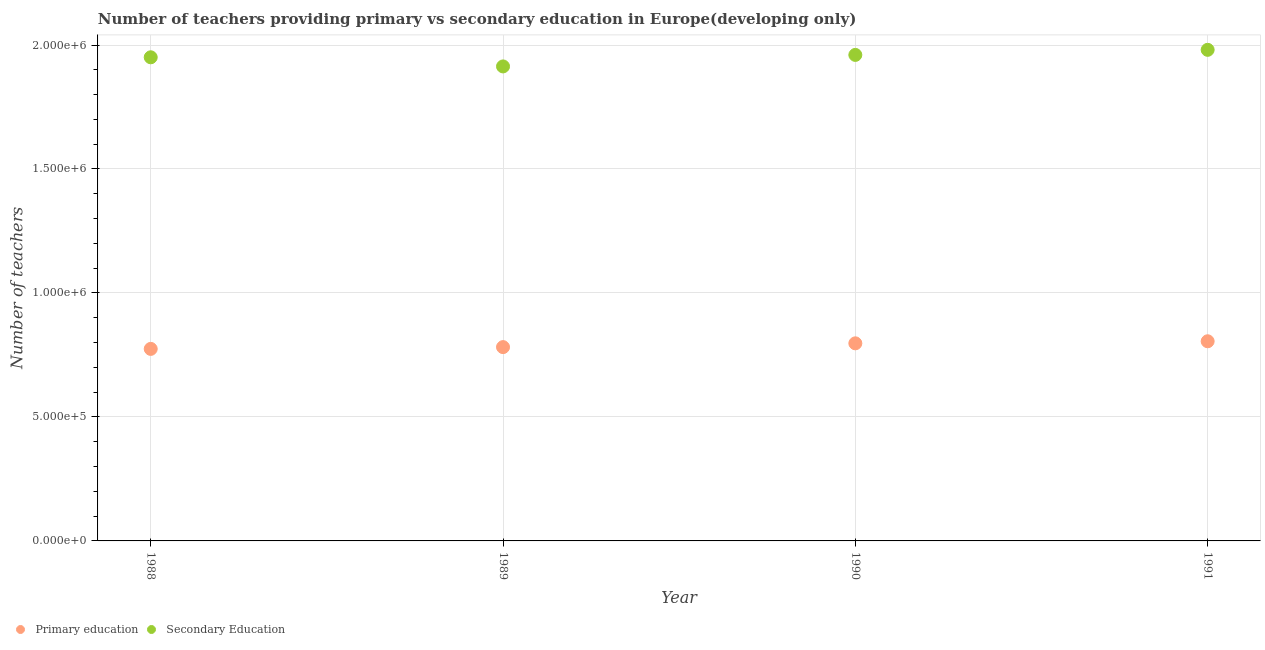What is the number of primary teachers in 1991?
Your answer should be compact. 8.05e+05. Across all years, what is the maximum number of primary teachers?
Make the answer very short. 8.05e+05. Across all years, what is the minimum number of secondary teachers?
Your response must be concise. 1.91e+06. In which year was the number of secondary teachers maximum?
Your answer should be very brief. 1991. What is the total number of primary teachers in the graph?
Give a very brief answer. 3.16e+06. What is the difference between the number of secondary teachers in 1989 and that in 1991?
Provide a succinct answer. -6.69e+04. What is the difference between the number of primary teachers in 1990 and the number of secondary teachers in 1991?
Your answer should be very brief. -1.18e+06. What is the average number of secondary teachers per year?
Give a very brief answer. 1.95e+06. In the year 1988, what is the difference between the number of primary teachers and number of secondary teachers?
Provide a succinct answer. -1.18e+06. What is the ratio of the number of primary teachers in 1988 to that in 1989?
Make the answer very short. 0.99. Is the difference between the number of primary teachers in 1989 and 1991 greater than the difference between the number of secondary teachers in 1989 and 1991?
Offer a very short reply. Yes. What is the difference between the highest and the second highest number of primary teachers?
Make the answer very short. 8311.06. What is the difference between the highest and the lowest number of primary teachers?
Make the answer very short. 3.07e+04. Is the sum of the number of secondary teachers in 1990 and 1991 greater than the maximum number of primary teachers across all years?
Offer a terse response. Yes. Is the number of secondary teachers strictly greater than the number of primary teachers over the years?
Your response must be concise. Yes. How many years are there in the graph?
Offer a terse response. 4. What is the difference between two consecutive major ticks on the Y-axis?
Provide a succinct answer. 5.00e+05. Does the graph contain any zero values?
Give a very brief answer. No. Does the graph contain grids?
Ensure brevity in your answer.  Yes. Where does the legend appear in the graph?
Offer a very short reply. Bottom left. How many legend labels are there?
Your answer should be compact. 2. How are the legend labels stacked?
Make the answer very short. Horizontal. What is the title of the graph?
Offer a terse response. Number of teachers providing primary vs secondary education in Europe(developing only). Does "Gasoline" appear as one of the legend labels in the graph?
Give a very brief answer. No. What is the label or title of the Y-axis?
Offer a very short reply. Number of teachers. What is the Number of teachers in Primary education in 1988?
Your response must be concise. 7.74e+05. What is the Number of teachers of Secondary Education in 1988?
Give a very brief answer. 1.95e+06. What is the Number of teachers in Primary education in 1989?
Keep it short and to the point. 7.82e+05. What is the Number of teachers of Secondary Education in 1989?
Give a very brief answer. 1.91e+06. What is the Number of teachers in Primary education in 1990?
Your answer should be compact. 7.97e+05. What is the Number of teachers in Secondary Education in 1990?
Your answer should be very brief. 1.96e+06. What is the Number of teachers in Primary education in 1991?
Your response must be concise. 8.05e+05. What is the Number of teachers in Secondary Education in 1991?
Ensure brevity in your answer.  1.98e+06. Across all years, what is the maximum Number of teachers in Primary education?
Keep it short and to the point. 8.05e+05. Across all years, what is the maximum Number of teachers in Secondary Education?
Make the answer very short. 1.98e+06. Across all years, what is the minimum Number of teachers in Primary education?
Provide a short and direct response. 7.74e+05. Across all years, what is the minimum Number of teachers in Secondary Education?
Give a very brief answer. 1.91e+06. What is the total Number of teachers of Primary education in the graph?
Ensure brevity in your answer.  3.16e+06. What is the total Number of teachers in Secondary Education in the graph?
Offer a terse response. 7.80e+06. What is the difference between the Number of teachers in Primary education in 1988 and that in 1989?
Your answer should be compact. -7168.81. What is the difference between the Number of teachers of Secondary Education in 1988 and that in 1989?
Your response must be concise. 3.68e+04. What is the difference between the Number of teachers in Primary education in 1988 and that in 1990?
Your answer should be very brief. -2.24e+04. What is the difference between the Number of teachers in Secondary Education in 1988 and that in 1990?
Offer a very short reply. -9607.5. What is the difference between the Number of teachers in Primary education in 1988 and that in 1991?
Keep it short and to the point. -3.07e+04. What is the difference between the Number of teachers in Secondary Education in 1988 and that in 1991?
Offer a very short reply. -3.01e+04. What is the difference between the Number of teachers of Primary education in 1989 and that in 1990?
Your answer should be very brief. -1.53e+04. What is the difference between the Number of teachers in Secondary Education in 1989 and that in 1990?
Offer a very short reply. -4.64e+04. What is the difference between the Number of teachers in Primary education in 1989 and that in 1991?
Offer a very short reply. -2.36e+04. What is the difference between the Number of teachers in Secondary Education in 1989 and that in 1991?
Provide a succinct answer. -6.69e+04. What is the difference between the Number of teachers in Primary education in 1990 and that in 1991?
Your answer should be compact. -8311.06. What is the difference between the Number of teachers in Secondary Education in 1990 and that in 1991?
Give a very brief answer. -2.05e+04. What is the difference between the Number of teachers in Primary education in 1988 and the Number of teachers in Secondary Education in 1989?
Offer a terse response. -1.14e+06. What is the difference between the Number of teachers of Primary education in 1988 and the Number of teachers of Secondary Education in 1990?
Provide a short and direct response. -1.19e+06. What is the difference between the Number of teachers in Primary education in 1988 and the Number of teachers in Secondary Education in 1991?
Provide a succinct answer. -1.21e+06. What is the difference between the Number of teachers in Primary education in 1989 and the Number of teachers in Secondary Education in 1990?
Offer a very short reply. -1.18e+06. What is the difference between the Number of teachers in Primary education in 1989 and the Number of teachers in Secondary Education in 1991?
Your answer should be compact. -1.20e+06. What is the difference between the Number of teachers of Primary education in 1990 and the Number of teachers of Secondary Education in 1991?
Provide a short and direct response. -1.18e+06. What is the average Number of teachers of Primary education per year?
Ensure brevity in your answer.  7.90e+05. What is the average Number of teachers in Secondary Education per year?
Your answer should be compact. 1.95e+06. In the year 1988, what is the difference between the Number of teachers of Primary education and Number of teachers of Secondary Education?
Your response must be concise. -1.18e+06. In the year 1989, what is the difference between the Number of teachers in Primary education and Number of teachers in Secondary Education?
Your answer should be very brief. -1.13e+06. In the year 1990, what is the difference between the Number of teachers in Primary education and Number of teachers in Secondary Education?
Provide a succinct answer. -1.16e+06. In the year 1991, what is the difference between the Number of teachers in Primary education and Number of teachers in Secondary Education?
Offer a very short reply. -1.18e+06. What is the ratio of the Number of teachers in Primary education in 1988 to that in 1989?
Offer a terse response. 0.99. What is the ratio of the Number of teachers in Secondary Education in 1988 to that in 1989?
Your answer should be very brief. 1.02. What is the ratio of the Number of teachers of Primary education in 1988 to that in 1990?
Offer a very short reply. 0.97. What is the ratio of the Number of teachers of Secondary Education in 1988 to that in 1990?
Offer a terse response. 1. What is the ratio of the Number of teachers in Primary education in 1988 to that in 1991?
Offer a terse response. 0.96. What is the ratio of the Number of teachers in Secondary Education in 1988 to that in 1991?
Provide a succinct answer. 0.98. What is the ratio of the Number of teachers of Primary education in 1989 to that in 1990?
Make the answer very short. 0.98. What is the ratio of the Number of teachers of Secondary Education in 1989 to that in 1990?
Make the answer very short. 0.98. What is the ratio of the Number of teachers of Primary education in 1989 to that in 1991?
Provide a succinct answer. 0.97. What is the ratio of the Number of teachers in Secondary Education in 1989 to that in 1991?
Offer a terse response. 0.97. What is the ratio of the Number of teachers in Primary education in 1990 to that in 1991?
Ensure brevity in your answer.  0.99. What is the ratio of the Number of teachers of Secondary Education in 1990 to that in 1991?
Give a very brief answer. 0.99. What is the difference between the highest and the second highest Number of teachers of Primary education?
Your answer should be compact. 8311.06. What is the difference between the highest and the second highest Number of teachers in Secondary Education?
Your answer should be compact. 2.05e+04. What is the difference between the highest and the lowest Number of teachers of Primary education?
Offer a terse response. 3.07e+04. What is the difference between the highest and the lowest Number of teachers of Secondary Education?
Your answer should be very brief. 6.69e+04. 